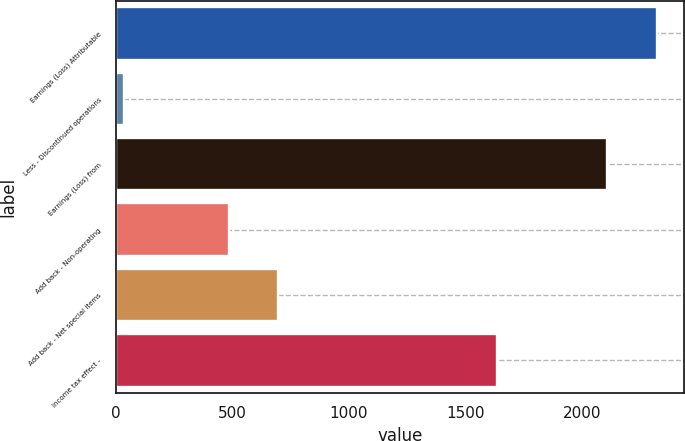Convert chart to OTSL. <chart><loc_0><loc_0><loc_500><loc_500><bar_chart><fcel>Earnings (Loss) Attributable<fcel>Less - Discontinued operations<fcel>Earnings (Loss) from<fcel>Add back - Non-operating<fcel>Add back - Net special items<fcel>Income tax effect -<nl><fcel>2321<fcel>34<fcel>2110<fcel>484<fcel>695<fcel>1634<nl></chart> 